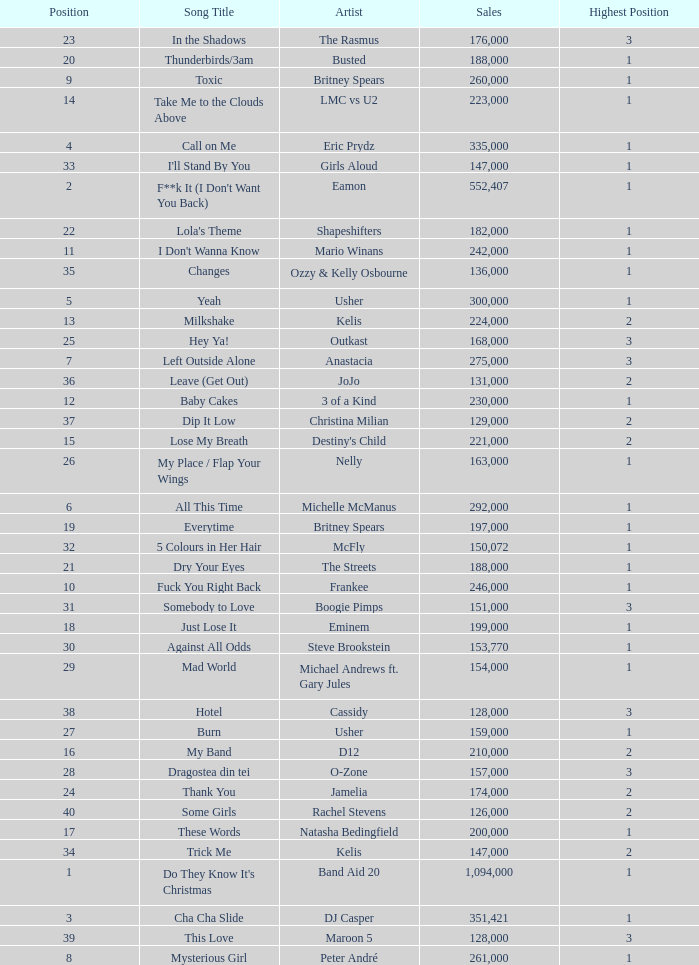What were the sales for Dj Casper when he was in a position lower than 13? 351421.0. Give me the full table as a dictionary. {'header': ['Position', 'Song Title', 'Artist', 'Sales', 'Highest Position'], 'rows': [['23', 'In the Shadows', 'The Rasmus', '176,000', '3'], ['20', 'Thunderbirds/3am', 'Busted', '188,000', '1'], ['9', 'Toxic', 'Britney Spears', '260,000', '1'], ['14', 'Take Me to the Clouds Above', 'LMC vs U2', '223,000', '1'], ['4', 'Call on Me', 'Eric Prydz', '335,000', '1'], ['33', "I'll Stand By You", 'Girls Aloud', '147,000', '1'], ['2', "F**k It (I Don't Want You Back)", 'Eamon', '552,407', '1'], ['22', "Lola's Theme", 'Shapeshifters', '182,000', '1'], ['11', "I Don't Wanna Know", 'Mario Winans', '242,000', '1'], ['35', 'Changes', 'Ozzy & Kelly Osbourne', '136,000', '1'], ['5', 'Yeah', 'Usher', '300,000', '1'], ['13', 'Milkshake', 'Kelis', '224,000', '2'], ['25', 'Hey Ya!', 'Outkast', '168,000', '3'], ['7', 'Left Outside Alone', 'Anastacia', '275,000', '3'], ['36', 'Leave (Get Out)', 'JoJo', '131,000', '2'], ['12', 'Baby Cakes', '3 of a Kind', '230,000', '1'], ['37', 'Dip It Low', 'Christina Milian', '129,000', '2'], ['15', 'Lose My Breath', "Destiny's Child", '221,000', '2'], ['26', 'My Place / Flap Your Wings', 'Nelly', '163,000', '1'], ['6', 'All This Time', 'Michelle McManus', '292,000', '1'], ['19', 'Everytime', 'Britney Spears', '197,000', '1'], ['32', '5 Colours in Her Hair', 'McFly', '150,072', '1'], ['21', 'Dry Your Eyes', 'The Streets', '188,000', '1'], ['10', 'Fuck You Right Back', 'Frankee', '246,000', '1'], ['31', 'Somebody to Love', 'Boogie Pimps', '151,000', '3'], ['18', 'Just Lose It', 'Eminem', '199,000', '1'], ['30', 'Against All Odds', 'Steve Brookstein', '153,770', '1'], ['29', 'Mad World', 'Michael Andrews ft. Gary Jules', '154,000', '1'], ['38', 'Hotel', 'Cassidy', '128,000', '3'], ['27', 'Burn', 'Usher', '159,000', '1'], ['16', 'My Band', 'D12', '210,000', '2'], ['28', 'Dragostea din tei', 'O-Zone', '157,000', '3'], ['24', 'Thank You', 'Jamelia', '174,000', '2'], ['40', 'Some Girls', 'Rachel Stevens', '126,000', '2'], ['17', 'These Words', 'Natasha Bedingfield', '200,000', '1'], ['34', 'Trick Me', 'Kelis', '147,000', '2'], ['1', "Do They Know It's Christmas", 'Band Aid 20', '1,094,000', '1'], ['3', 'Cha Cha Slide', 'DJ Casper', '351,421', '1'], ['39', 'This Love', 'Maroon 5', '128,000', '3'], ['8', 'Mysterious Girl', 'Peter André', '261,000', '1']]} 